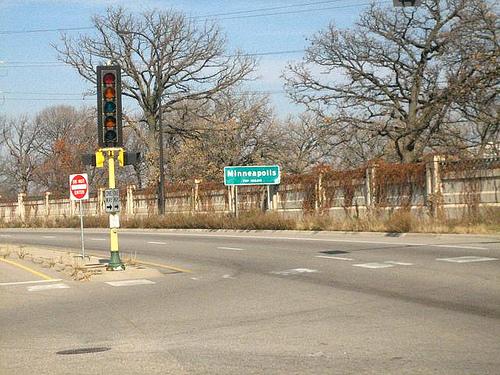How many trees are there?
Give a very brief answer. Many. Is this picture outdoors?
Be succinct. Yes. What State in the U.S.A has this picture been taken in?
Write a very short answer. Minnesota. 